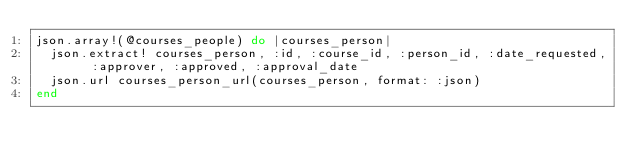<code> <loc_0><loc_0><loc_500><loc_500><_Ruby_>json.array!(@courses_people) do |courses_person|
  json.extract! courses_person, :id, :course_id, :person_id, :date_requested, :approver, :approved, :approval_date
  json.url courses_person_url(courses_person, format: :json)
end
</code> 